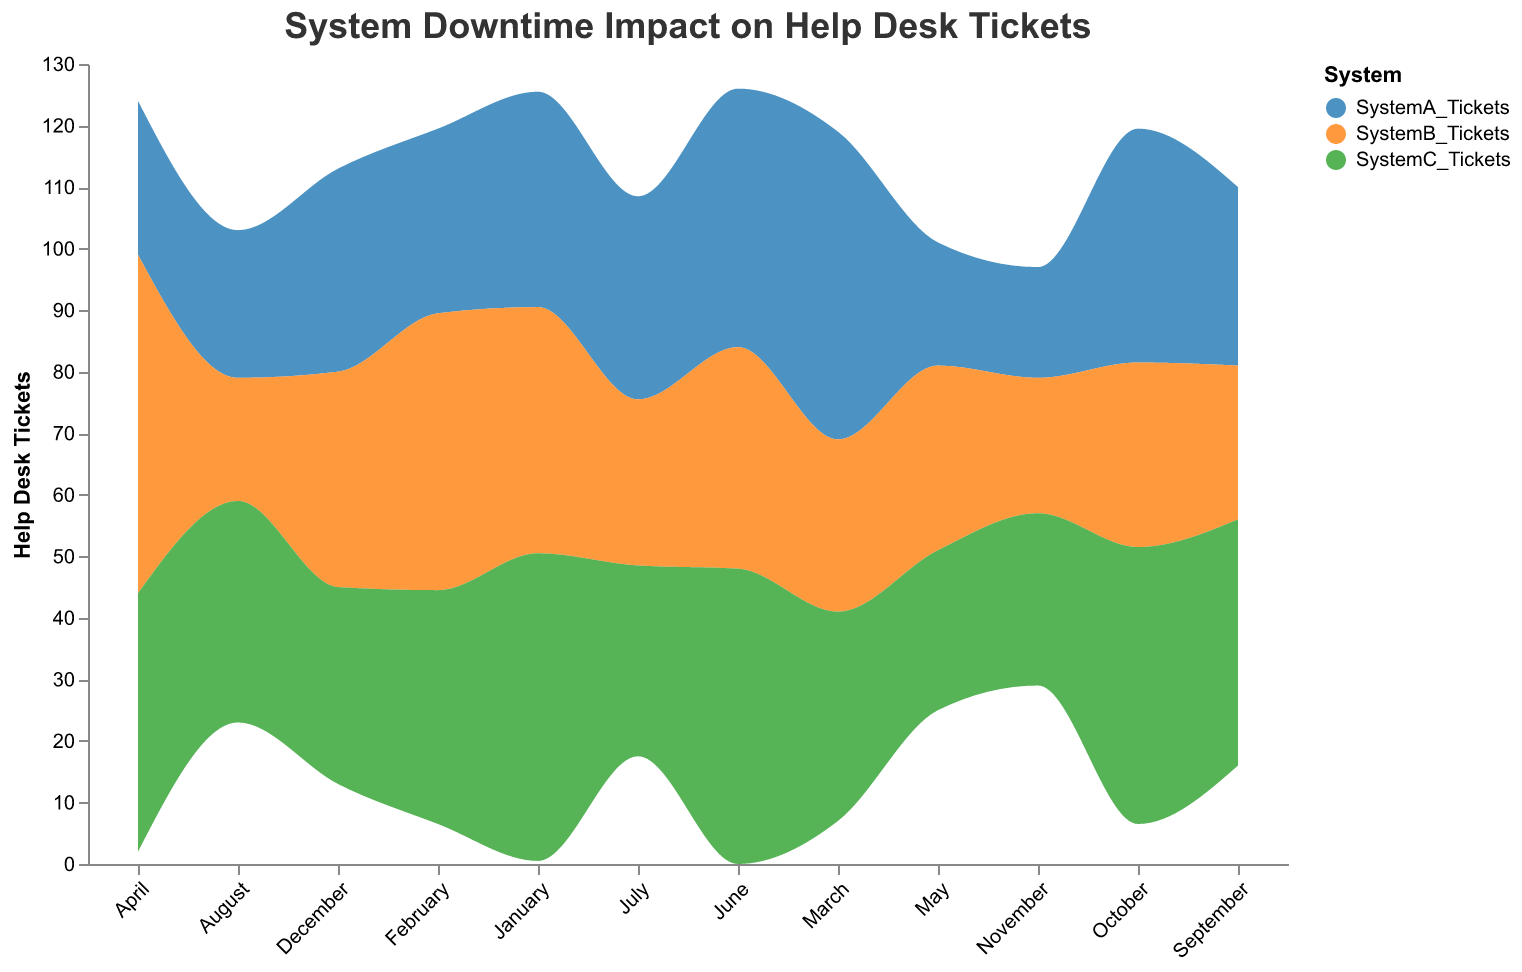What is the title of the figure? The title is prominently displayed at the top of the figure, usually in larger font size.
Answer: System Downtime Impact on Help Desk Tickets Which system has the most help desk tickets in March? Looking at the March data segment, SystemA_Tickets, SystemB_Tickets, and SystemC_Tickets are visualized. The highest area for March corresponds to SystemA_Tickets.
Answer: SystemA How many help desk tickets did System B have in April? Hovering or looking closely at the segment for System B in April reveals the tooltip showing the number of tickets.
Answer: 55 Which month had the highest total number of help desk tickets across all systems? Sum the ticket values for each month and compare. April has the highest combined ticket count for SystemA_Tickets, SystemB_Tickets, and SystemC_Tickets.
Answer: April How does the downtime of System A in January compare to that in February? Refer to the values of SystemA_Downtime for January and February. January has 10 hours of downtime, and February has 5 hours. So, January had more downtime.
Answer: January had more downtime What is the average number of tickets generated by System C in the first quarter of the year? Add the tickets for System C in January, February, and March, then divide by 3. (50 + 38 + 34) / 3 equals 40.67.
Answer: 40.67 Which system exhibited the least volatility in help desk tickets across the months? Observe the stream layers for each system and notice the smoothest layer. SystemB_Tickets appears more stable compared to others.
Answer: System B What was the total number of help desk tickets for System A throughout the year? Sum all the monthly help desk tickets for System A: (35 + 30 + 50 + 25 + 20 + 42 + 33 + 24 + 29 + 38 + 18 + 33) = 377.
Answer: 377 In which month did System C have its largest increase in help desk tickets compared to the previous month? Observe the height changes between consecutive months for SystemC_Tickets, the steepest increase is from July (31) to August (36), which is an increase of 5 tickets.
Answer: August How does the volume of help desk tickets in December compare across all systems? Look at the different layers for December's value; System A has 33, System B has 35, and System C has 32 tickets. Hence, System B has the most tickets, followed by System A, and then System C.
Answer: System B > System A > System C 